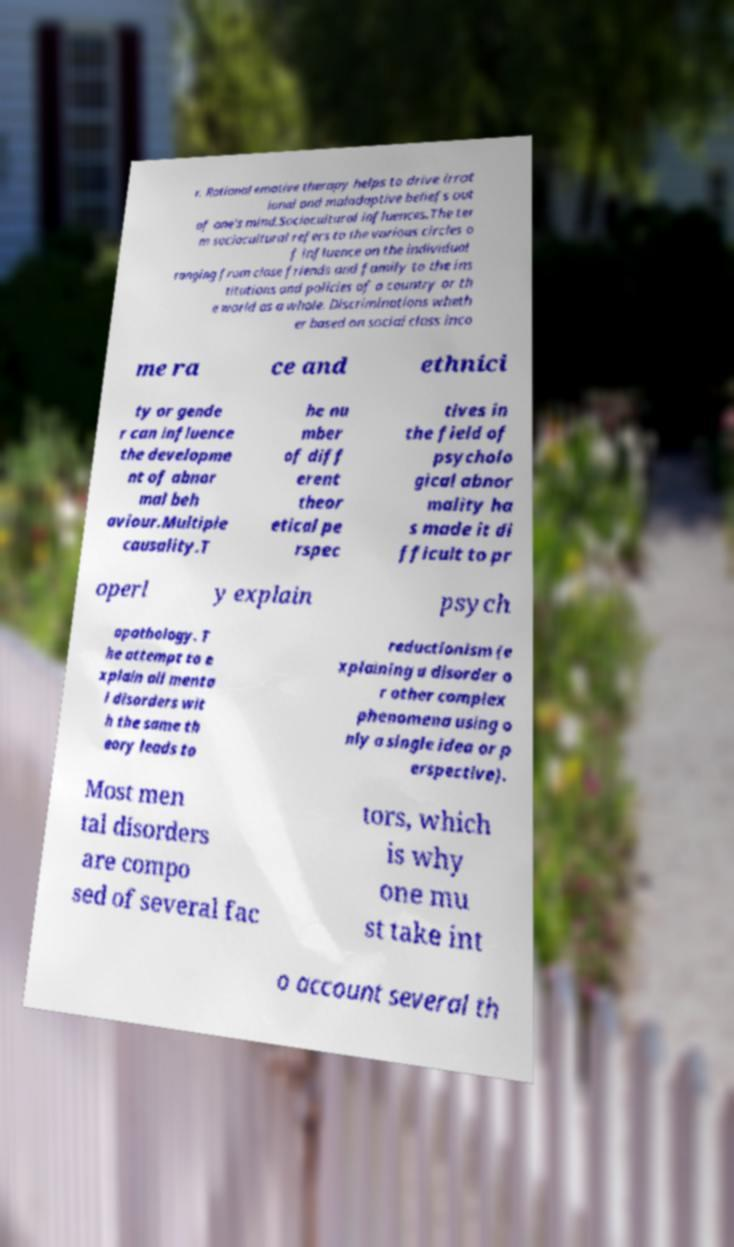Please identify and transcribe the text found in this image. r. Rational emotive therapy helps to drive irrat ional and maladaptive beliefs out of one's mind.Sociocultural influences.The ter m sociocultural refers to the various circles o f influence on the individual ranging from close friends and family to the ins titutions and policies of a country or th e world as a whole. Discriminations wheth er based on social class inco me ra ce and ethnici ty or gende r can influence the developme nt of abnor mal beh aviour.Multiple causality.T he nu mber of diff erent theor etical pe rspec tives in the field of psycholo gical abnor mality ha s made it di fficult to pr operl y explain psych opathology. T he attempt to e xplain all menta l disorders wit h the same th eory leads to reductionism (e xplaining a disorder o r other complex phenomena using o nly a single idea or p erspective). Most men tal disorders are compo sed of several fac tors, which is why one mu st take int o account several th 